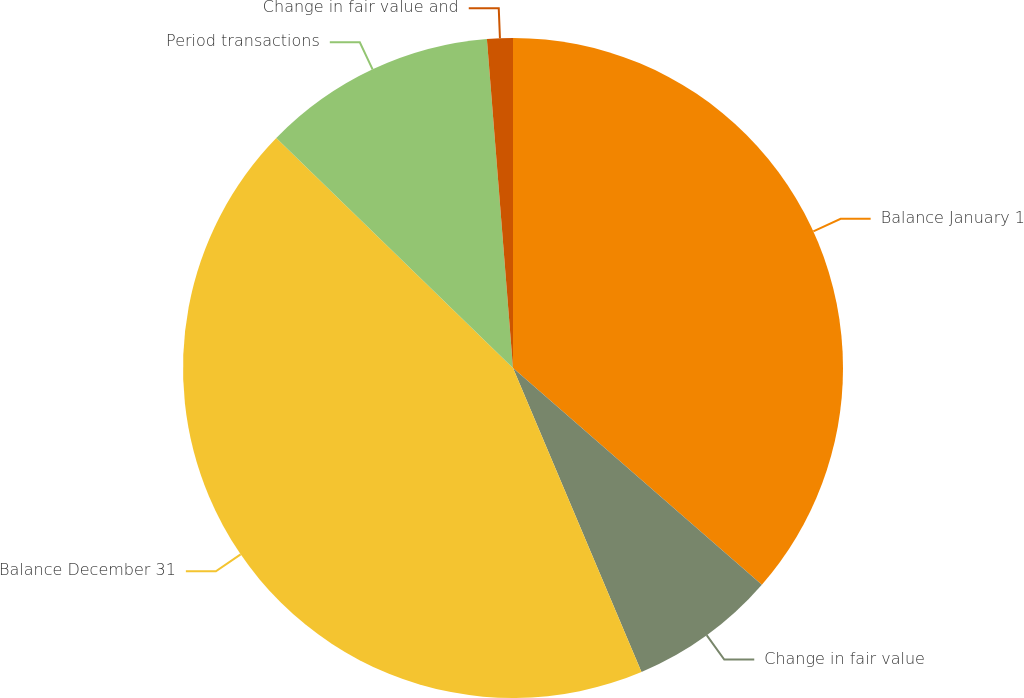Convert chart to OTSL. <chart><loc_0><loc_0><loc_500><loc_500><pie_chart><fcel>Balance January 1<fcel>Change in fair value<fcel>Balance December 31<fcel>Period transactions<fcel>Change in fair value and<nl><fcel>36.4%<fcel>7.23%<fcel>43.63%<fcel>11.47%<fcel>1.26%<nl></chart> 